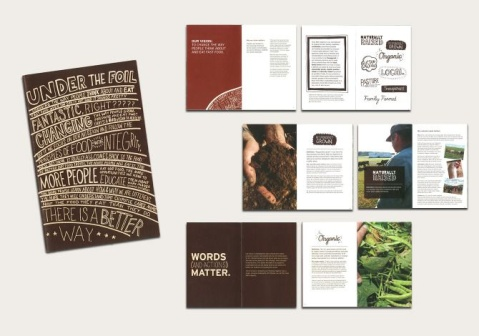What is this photo about? The image depicts a collection of nine printed materials, likely promotional in nature, arranged neatly so that their designs are clearly visible. These include a mix of brochures, flyers, and booklets that feature an eco-friendly design aesthetic with a predominant color scheme of white, accented with brown and green. Noteworthy phrases like 'UNDER THE FOIL' and 'Words Matter' suggest themes of sustainability and the importance of transparent communication. The integration of food and plant imagery aligns with a probable focus on agriculture or organic products, underlining the materials' commitment to promoting environmentally conscious choices. 